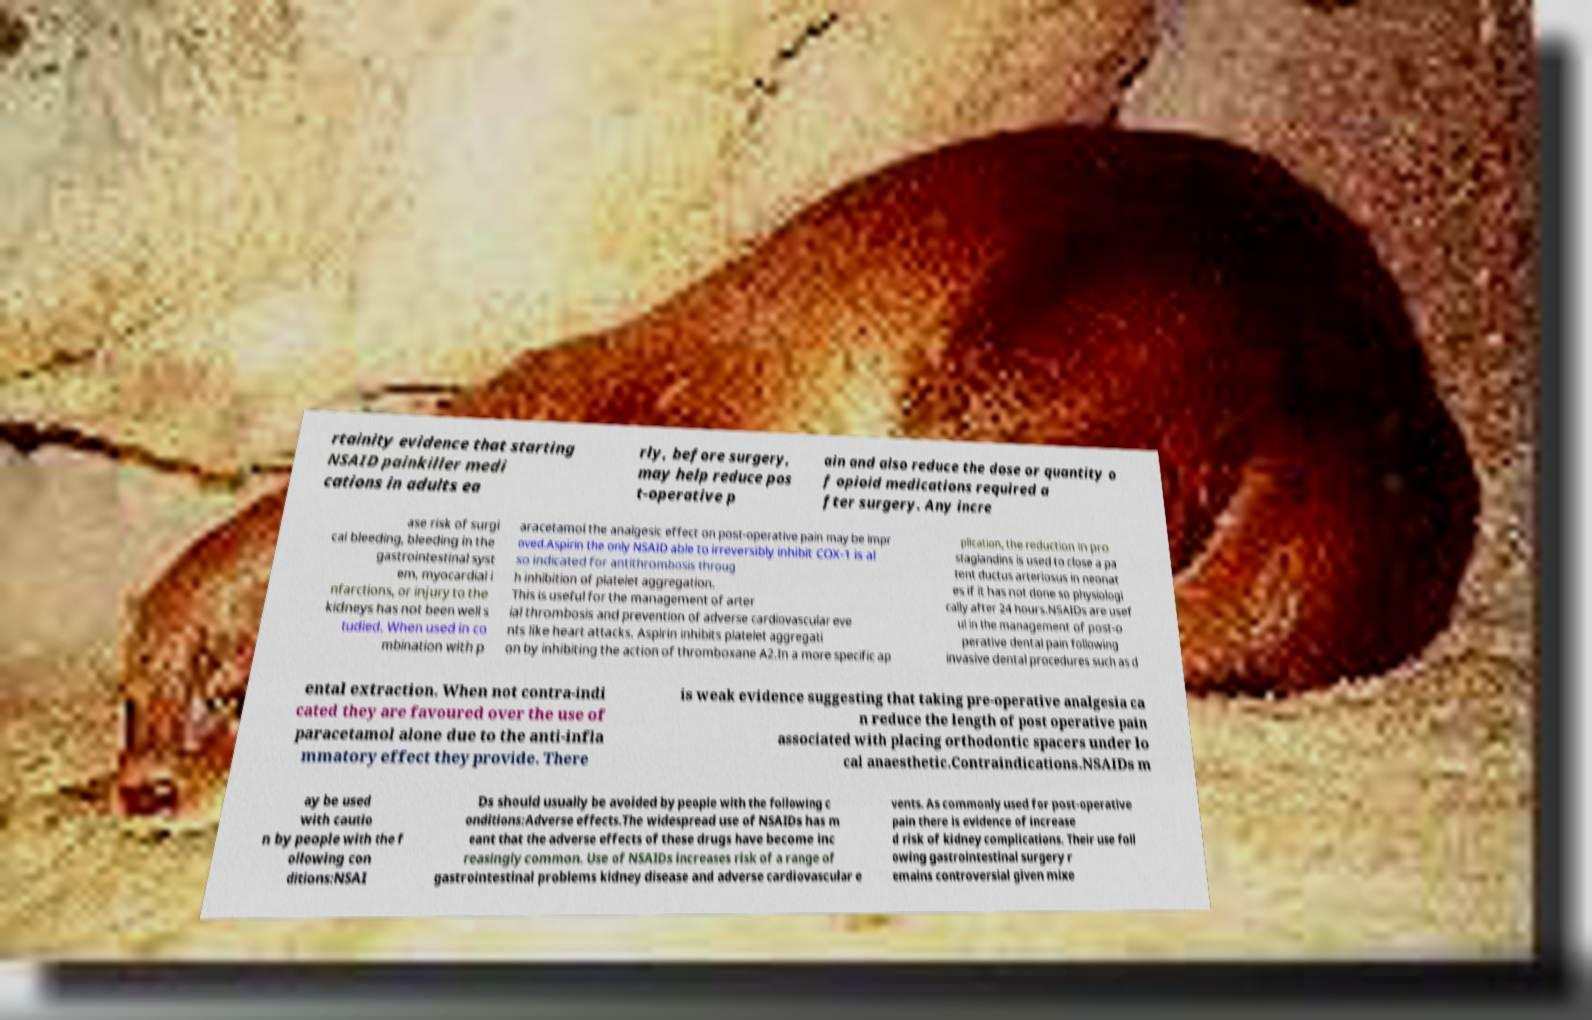I need the written content from this picture converted into text. Can you do that? rtainity evidence that starting NSAID painkiller medi cations in adults ea rly, before surgery, may help reduce pos t-operative p ain and also reduce the dose or quantity o f opioid medications required a fter surgery. Any incre ase risk of surgi cal bleeding, bleeding in the gastrointestinal syst em, myocardial i nfarctions, or injury to the kidneys has not been well s tudied. When used in co mbination with p aracetamol the analgesic effect on post-operative pain may be impr oved.Aspirin the only NSAID able to irreversibly inhibit COX-1 is al so indicated for antithrombosis throug h inhibition of platelet aggregation. This is useful for the management of arter ial thrombosis and prevention of adverse cardiovascular eve nts like heart attacks. Aspirin inhibits platelet aggregati on by inhibiting the action of thromboxane A2.In a more specific ap plication, the reduction in pro staglandins is used to close a pa tent ductus arteriosus in neonat es if it has not done so physiologi cally after 24 hours.NSAIDs are usef ul in the management of post-o perative dental pain following invasive dental procedures such as d ental extraction. When not contra-indi cated they are favoured over the use of paracetamol alone due to the anti-infla mmatory effect they provide. There is weak evidence suggesting that taking pre-operative analgesia ca n reduce the length of post operative pain associated with placing orthodontic spacers under lo cal anaesthetic.Contraindications.NSAIDs m ay be used with cautio n by people with the f ollowing con ditions:NSAI Ds should usually be avoided by people with the following c onditions:Adverse effects.The widespread use of NSAIDs has m eant that the adverse effects of these drugs have become inc reasingly common. Use of NSAIDs increases risk of a range of gastrointestinal problems kidney disease and adverse cardiovascular e vents. As commonly used for post-operative pain there is evidence of increase d risk of kidney complications. Their use foll owing gastrointestinal surgery r emains controversial given mixe 